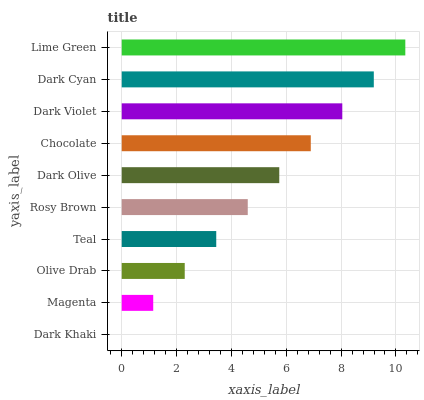Is Dark Khaki the minimum?
Answer yes or no. Yes. Is Lime Green the maximum?
Answer yes or no. Yes. Is Magenta the minimum?
Answer yes or no. No. Is Magenta the maximum?
Answer yes or no. No. Is Magenta greater than Dark Khaki?
Answer yes or no. Yes. Is Dark Khaki less than Magenta?
Answer yes or no. Yes. Is Dark Khaki greater than Magenta?
Answer yes or no. No. Is Magenta less than Dark Khaki?
Answer yes or no. No. Is Dark Olive the high median?
Answer yes or no. Yes. Is Rosy Brown the low median?
Answer yes or no. Yes. Is Chocolate the high median?
Answer yes or no. No. Is Magenta the low median?
Answer yes or no. No. 